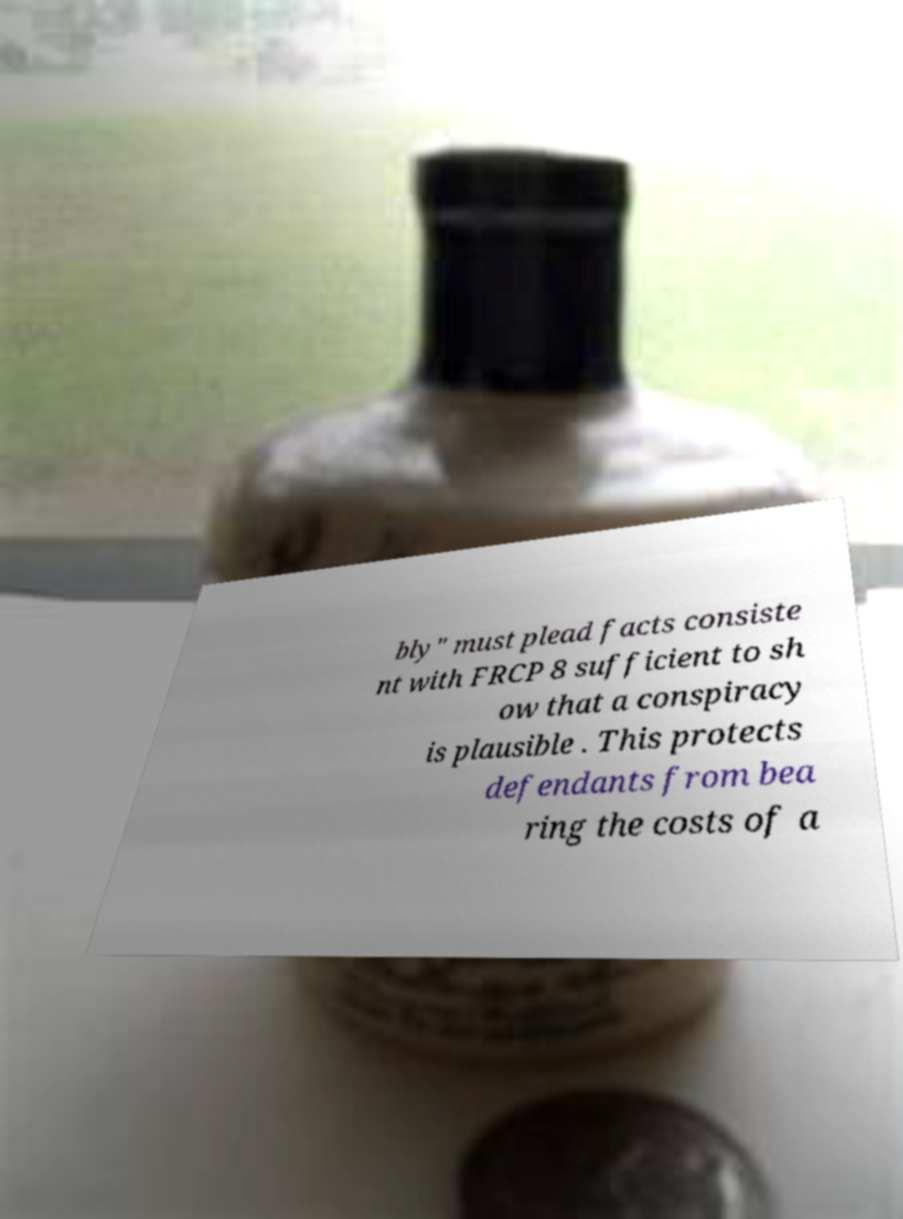Please read and relay the text visible in this image. What does it say? bly" must plead facts consiste nt with FRCP 8 sufficient to sh ow that a conspiracy is plausible . This protects defendants from bea ring the costs of a 